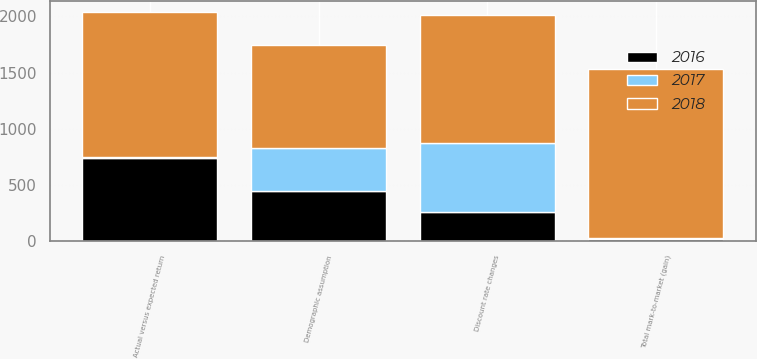Convert chart to OTSL. <chart><loc_0><loc_0><loc_500><loc_500><stacked_bar_chart><ecel><fcel>Discount rate changes<fcel>Demographic assumption<fcel>Actual versus expected return<fcel>Total mark-to-market (gain)<nl><fcel>2017<fcel>613<fcel>382<fcel>11<fcel>10<nl><fcel>2016<fcel>266<fcel>450<fcel>740<fcel>24<nl><fcel>2018<fcel>1129<fcel>916<fcel>1285<fcel>1498<nl></chart> 